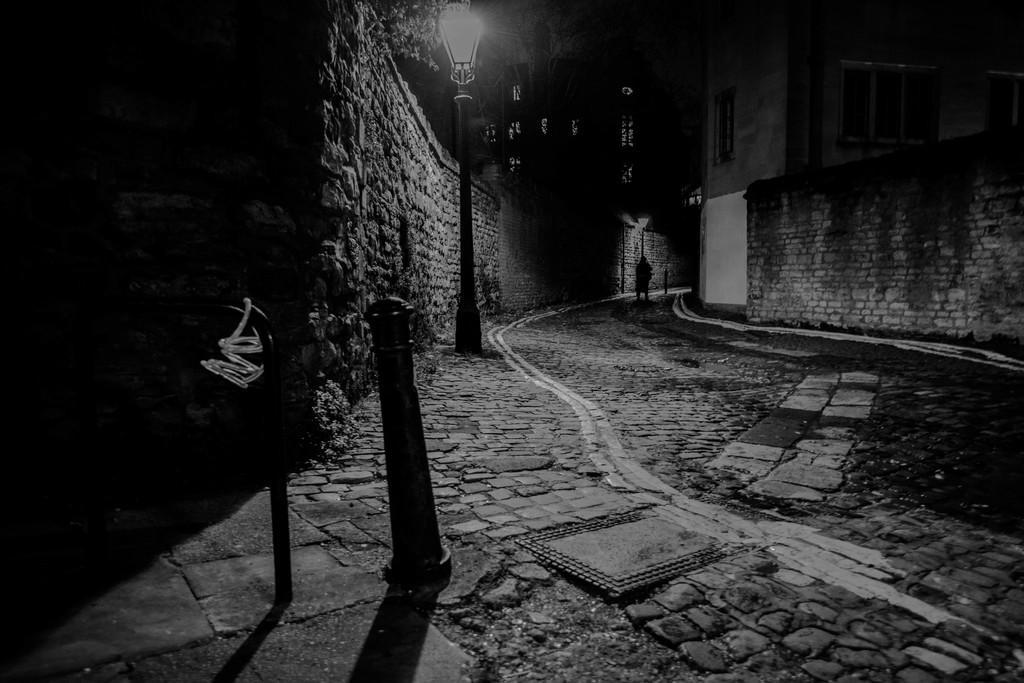How would you summarize this image in a sentence or two? There is a wall and a street light in the left corner and there is a building in the right corner and there is person standing in the background. 